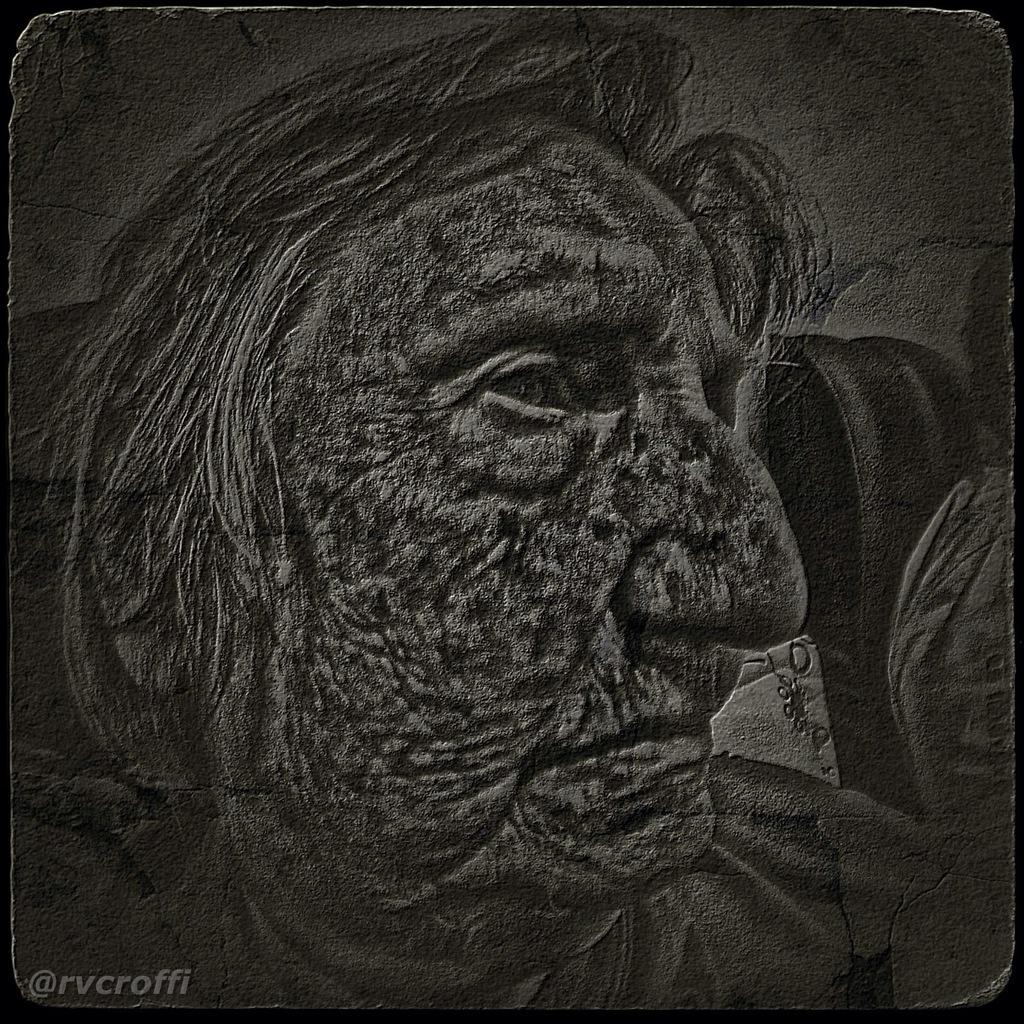What can be observed about the image's appearance? The image is edited. What additional information is present on the image? There is text written on the image. How many frames are visible in the image? There is no reference to frames in the image, as it is a single image with text. What type of fowl can be seen in the image? There is no fowl present in the image; it only contains text and has been edited. 